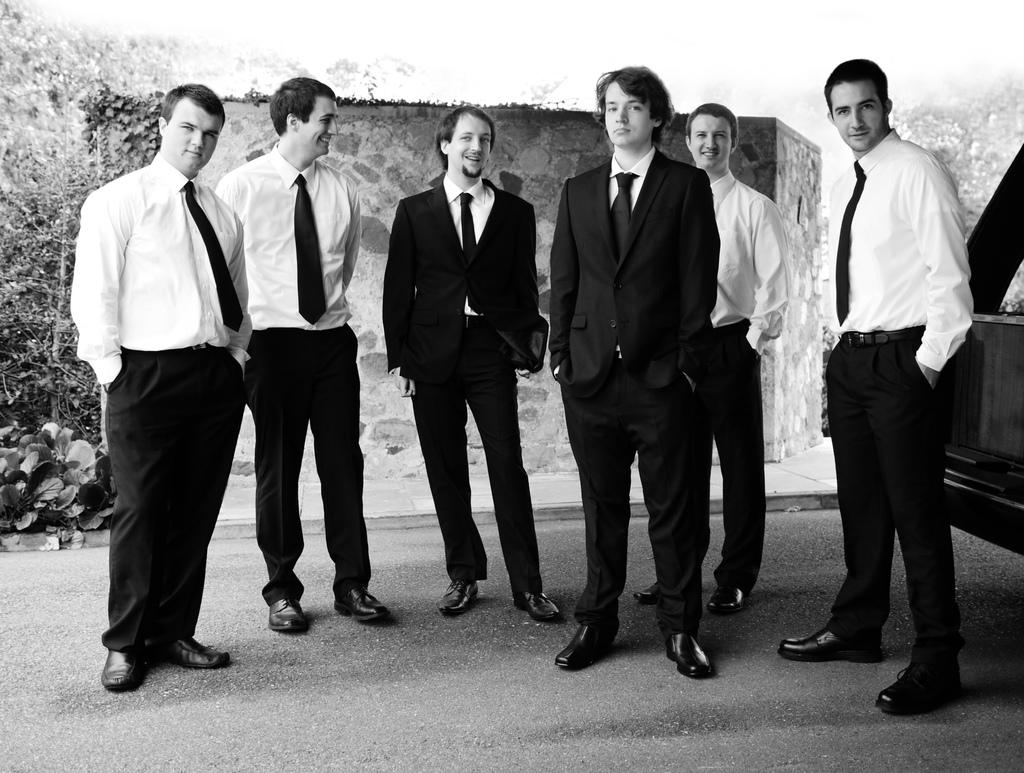What can be seen in the image? There are persons standing in the image. What is the color scheme of the image? The image is black and white. What is visible in the background of the image? There is a stone wall and trees in the background of the image. What type of church can be seen in the image? There is no church present in the image; it features persons standing in front of a stone wall and trees. What is the mind of the person in the image thinking? The image does not provide any information about the thoughts or mental state of the persons in the image. 